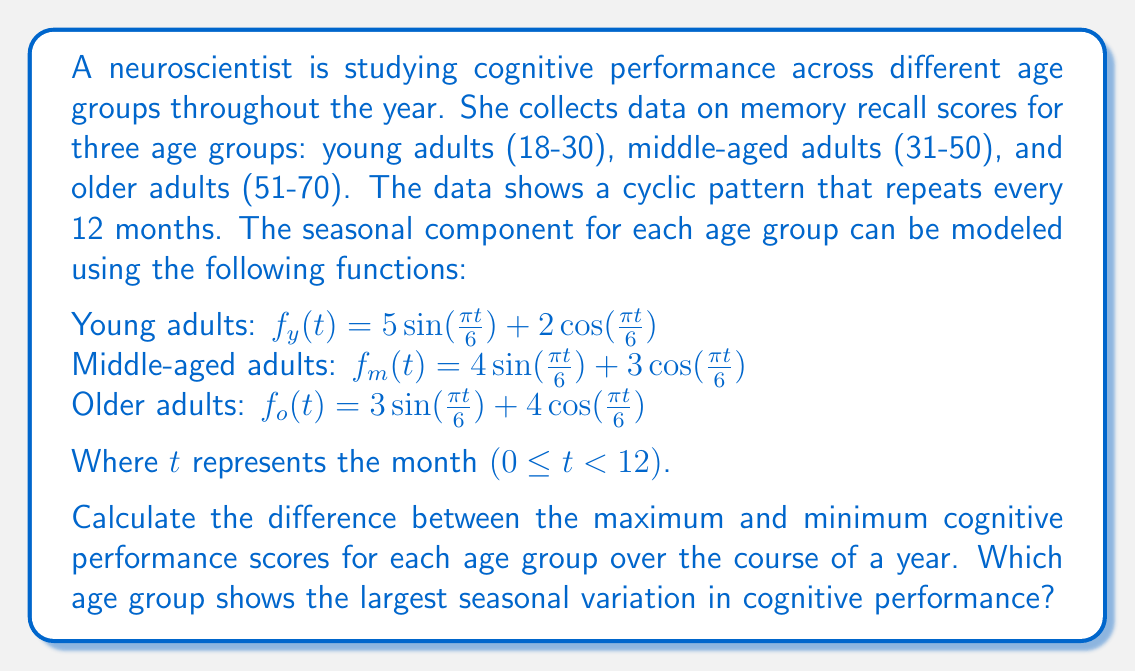Help me with this question. To solve this problem, we need to find the maximum and minimum values for each function over the course of a year (0 ≤ t < 12) and then calculate the difference.

For a function of the form $f(t) = A \sin(\frac{\pi t}{6}) + B \cos(\frac{\pi t}{6})$, the maximum and minimum values can be found using the formula:

$$\text{Max/Min} = \pm\sqrt{A^2 + B^2}$$

Where the positive value gives the maximum, and the negative value gives the minimum.

Let's calculate for each age group:

1. Young adults: $f_y(t) = 5 \sin(\frac{\pi t}{6}) + 2 \cos(\frac{\pi t}{6})$
   $A = 5, B = 2$
   $\text{Max} = \sqrt{5^2 + 2^2} = \sqrt{29} \approx 5.39$
   $\text{Min} = -\sqrt{29} \approx -5.39$
   $\text{Difference} = 5.39 - (-5.39) = 10.78$

2. Middle-aged adults: $f_m(t) = 4 \sin(\frac{\pi t}{6}) + 3 \cos(\frac{\pi t}{6})$
   $A = 4, B = 3$
   $\text{Max} = \sqrt{4^2 + 3^2} = \sqrt{25} = 5$
   $\text{Min} = -5$
   $\text{Difference} = 5 - (-5) = 10$

3. Older adults: $f_o(t) = 3 \sin(\frac{\pi t}{6}) + 4 \cos(\frac{\pi t}{6})$
   $A = 3, B = 4$
   $\text{Max} = \sqrt{3^2 + 4^2} = \sqrt{25} = 5$
   $\text{Min} = -5$
   $\text{Difference} = 5 - (-5) = 10$

Comparing the differences:
Young adults: 10.78
Middle-aged adults: 10
Older adults: 10

The young adult group shows the largest seasonal variation in cognitive performance.
Answer: The young adult group (18-30) shows the largest seasonal variation in cognitive performance, with a difference of approximately 10.78 between the maximum and minimum scores. 